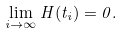<formula> <loc_0><loc_0><loc_500><loc_500>\lim _ { i \rightarrow \infty } H ( t _ { i } ) = 0 .</formula> 